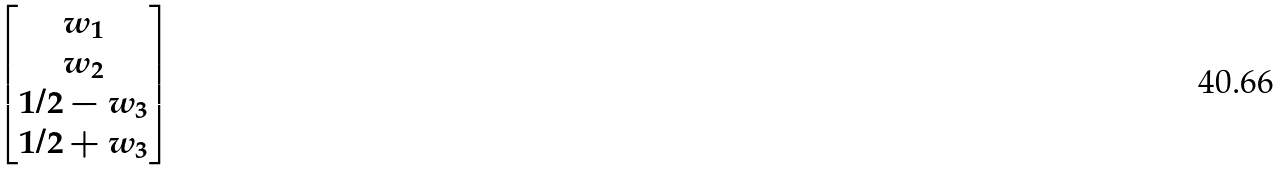Convert formula to latex. <formula><loc_0><loc_0><loc_500><loc_500>\begin{bmatrix} w _ { 1 } \\ w _ { 2 } \\ 1 / 2 - w _ { 3 } \\ 1 / 2 + w _ { 3 } \end{bmatrix}</formula> 